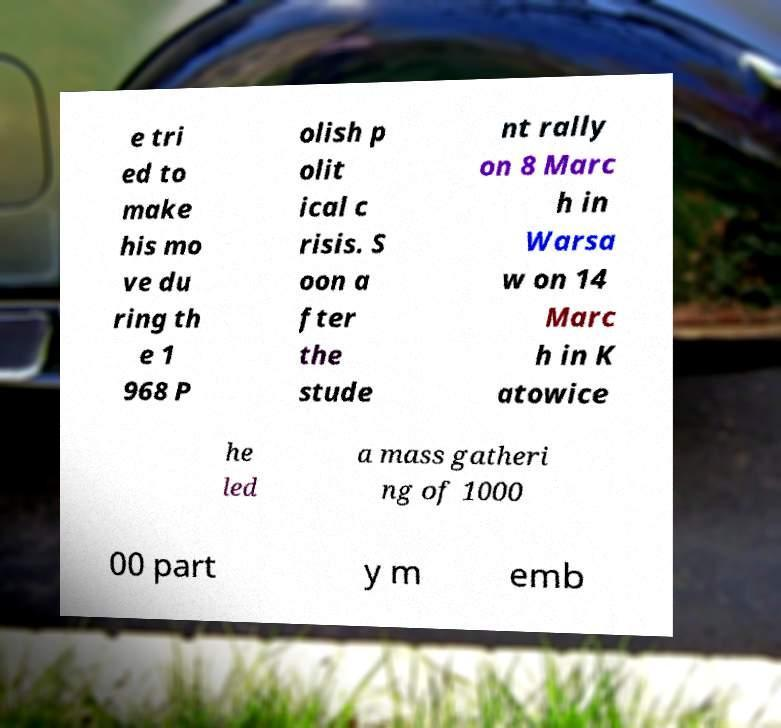There's text embedded in this image that I need extracted. Can you transcribe it verbatim? e tri ed to make his mo ve du ring th e 1 968 P olish p olit ical c risis. S oon a fter the stude nt rally on 8 Marc h in Warsa w on 14 Marc h in K atowice he led a mass gatheri ng of 1000 00 part y m emb 